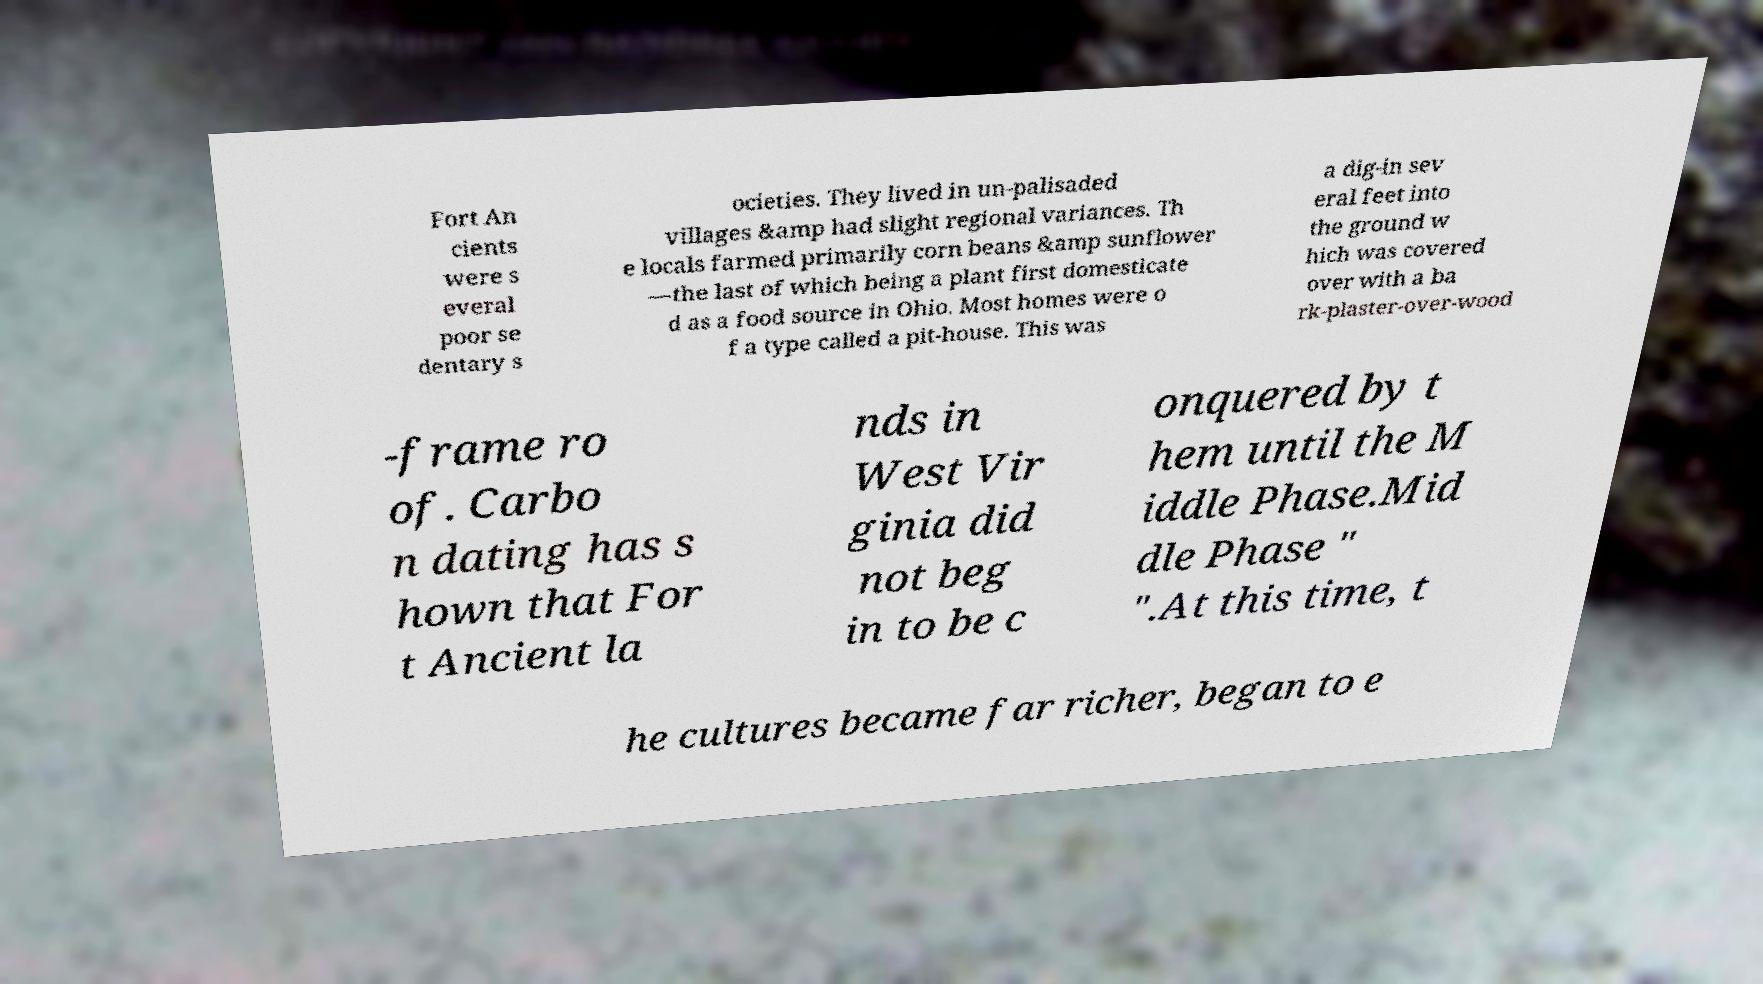Can you read and provide the text displayed in the image?This photo seems to have some interesting text. Can you extract and type it out for me? Fort An cients were s everal poor se dentary s ocieties. They lived in un-palisaded villages &amp had slight regional variances. Th e locals farmed primarily corn beans &amp sunflower —the last of which being a plant first domesticate d as a food source in Ohio. Most homes were o f a type called a pit-house. This was a dig-in sev eral feet into the ground w hich was covered over with a ba rk-plaster-over-wood -frame ro of. Carbo n dating has s hown that For t Ancient la nds in West Vir ginia did not beg in to be c onquered by t hem until the M iddle Phase.Mid dle Phase " ".At this time, t he cultures became far richer, began to e 